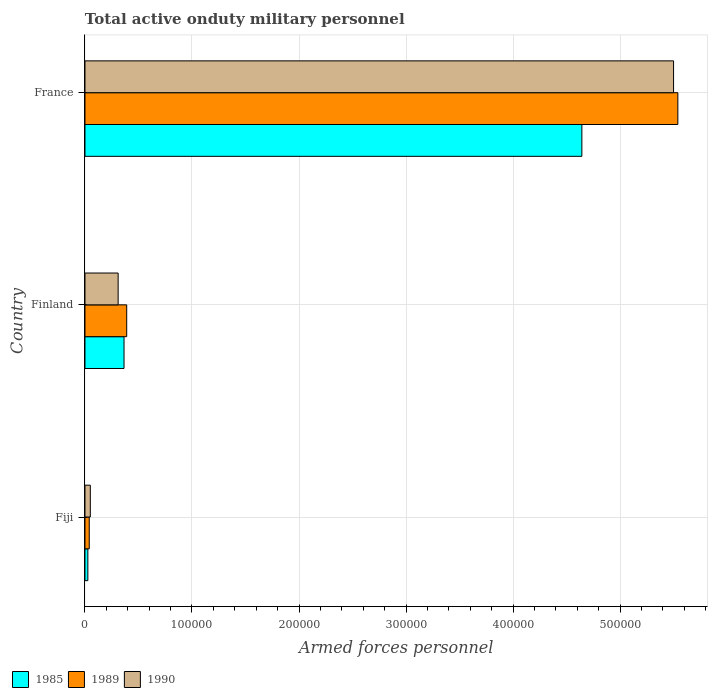How many different coloured bars are there?
Ensure brevity in your answer.  3. How many groups of bars are there?
Offer a terse response. 3. How many bars are there on the 3rd tick from the bottom?
Keep it short and to the point. 3. What is the label of the 3rd group of bars from the top?
Offer a terse response. Fiji. In how many cases, is the number of bars for a given country not equal to the number of legend labels?
Make the answer very short. 0. What is the number of armed forces personnel in 1989 in France?
Provide a short and direct response. 5.54e+05. Across all countries, what is the maximum number of armed forces personnel in 1990?
Offer a terse response. 5.50e+05. Across all countries, what is the minimum number of armed forces personnel in 1989?
Offer a terse response. 4000. In which country was the number of armed forces personnel in 1989 maximum?
Your response must be concise. France. In which country was the number of armed forces personnel in 1990 minimum?
Ensure brevity in your answer.  Fiji. What is the total number of armed forces personnel in 1990 in the graph?
Give a very brief answer. 5.86e+05. What is the difference between the number of armed forces personnel in 1990 in Fiji and that in France?
Ensure brevity in your answer.  -5.45e+05. What is the difference between the number of armed forces personnel in 1989 in Finland and the number of armed forces personnel in 1990 in France?
Your answer should be very brief. -5.11e+05. What is the average number of armed forces personnel in 1989 per country?
Your answer should be very brief. 1.99e+05. What is the difference between the number of armed forces personnel in 1989 and number of armed forces personnel in 1990 in Finland?
Offer a terse response. 8000. What is the ratio of the number of armed forces personnel in 1989 in Fiji to that in France?
Make the answer very short. 0.01. Is the difference between the number of armed forces personnel in 1989 in Finland and France greater than the difference between the number of armed forces personnel in 1990 in Finland and France?
Offer a terse response. Yes. What is the difference between the highest and the second highest number of armed forces personnel in 1985?
Offer a terse response. 4.28e+05. What is the difference between the highest and the lowest number of armed forces personnel in 1990?
Ensure brevity in your answer.  5.45e+05. Is the sum of the number of armed forces personnel in 1990 in Finland and France greater than the maximum number of armed forces personnel in 1989 across all countries?
Give a very brief answer. Yes. What does the 2nd bar from the top in France represents?
Keep it short and to the point. 1989. Is it the case that in every country, the sum of the number of armed forces personnel in 1989 and number of armed forces personnel in 1990 is greater than the number of armed forces personnel in 1985?
Your answer should be very brief. Yes. Are all the bars in the graph horizontal?
Keep it short and to the point. Yes. Where does the legend appear in the graph?
Provide a succinct answer. Bottom left. How are the legend labels stacked?
Offer a very short reply. Horizontal. What is the title of the graph?
Give a very brief answer. Total active onduty military personnel. Does "1993" appear as one of the legend labels in the graph?
Your response must be concise. No. What is the label or title of the X-axis?
Provide a succinct answer. Armed forces personnel. What is the label or title of the Y-axis?
Offer a very short reply. Country. What is the Armed forces personnel of 1985 in Fiji?
Your response must be concise. 2700. What is the Armed forces personnel in 1989 in Fiji?
Provide a succinct answer. 4000. What is the Armed forces personnel in 1990 in Fiji?
Make the answer very short. 5000. What is the Armed forces personnel of 1985 in Finland?
Offer a very short reply. 3.65e+04. What is the Armed forces personnel of 1989 in Finland?
Offer a terse response. 3.90e+04. What is the Armed forces personnel of 1990 in Finland?
Your answer should be compact. 3.10e+04. What is the Armed forces personnel of 1985 in France?
Provide a succinct answer. 4.64e+05. What is the Armed forces personnel in 1989 in France?
Offer a terse response. 5.54e+05. What is the Armed forces personnel in 1990 in France?
Ensure brevity in your answer.  5.50e+05. Across all countries, what is the maximum Armed forces personnel in 1985?
Your answer should be compact. 4.64e+05. Across all countries, what is the maximum Armed forces personnel of 1989?
Your response must be concise. 5.54e+05. Across all countries, what is the maximum Armed forces personnel in 1990?
Give a very brief answer. 5.50e+05. Across all countries, what is the minimum Armed forces personnel in 1985?
Your response must be concise. 2700. Across all countries, what is the minimum Armed forces personnel of 1989?
Your answer should be compact. 4000. Across all countries, what is the minimum Armed forces personnel of 1990?
Give a very brief answer. 5000. What is the total Armed forces personnel of 1985 in the graph?
Provide a succinct answer. 5.04e+05. What is the total Armed forces personnel in 1989 in the graph?
Give a very brief answer. 5.97e+05. What is the total Armed forces personnel of 1990 in the graph?
Make the answer very short. 5.86e+05. What is the difference between the Armed forces personnel of 1985 in Fiji and that in Finland?
Provide a short and direct response. -3.38e+04. What is the difference between the Armed forces personnel of 1989 in Fiji and that in Finland?
Keep it short and to the point. -3.50e+04. What is the difference between the Armed forces personnel of 1990 in Fiji and that in Finland?
Keep it short and to the point. -2.60e+04. What is the difference between the Armed forces personnel of 1985 in Fiji and that in France?
Ensure brevity in your answer.  -4.62e+05. What is the difference between the Armed forces personnel in 1989 in Fiji and that in France?
Your answer should be compact. -5.50e+05. What is the difference between the Armed forces personnel of 1990 in Fiji and that in France?
Provide a succinct answer. -5.45e+05. What is the difference between the Armed forces personnel of 1985 in Finland and that in France?
Keep it short and to the point. -4.28e+05. What is the difference between the Armed forces personnel in 1989 in Finland and that in France?
Provide a succinct answer. -5.15e+05. What is the difference between the Armed forces personnel in 1990 in Finland and that in France?
Your answer should be very brief. -5.19e+05. What is the difference between the Armed forces personnel of 1985 in Fiji and the Armed forces personnel of 1989 in Finland?
Keep it short and to the point. -3.63e+04. What is the difference between the Armed forces personnel of 1985 in Fiji and the Armed forces personnel of 1990 in Finland?
Ensure brevity in your answer.  -2.83e+04. What is the difference between the Armed forces personnel of 1989 in Fiji and the Armed forces personnel of 1990 in Finland?
Keep it short and to the point. -2.70e+04. What is the difference between the Armed forces personnel of 1985 in Fiji and the Armed forces personnel of 1989 in France?
Provide a succinct answer. -5.51e+05. What is the difference between the Armed forces personnel of 1985 in Fiji and the Armed forces personnel of 1990 in France?
Keep it short and to the point. -5.47e+05. What is the difference between the Armed forces personnel in 1989 in Fiji and the Armed forces personnel in 1990 in France?
Offer a very short reply. -5.46e+05. What is the difference between the Armed forces personnel in 1985 in Finland and the Armed forces personnel in 1989 in France?
Provide a short and direct response. -5.18e+05. What is the difference between the Armed forces personnel of 1985 in Finland and the Armed forces personnel of 1990 in France?
Give a very brief answer. -5.14e+05. What is the difference between the Armed forces personnel in 1989 in Finland and the Armed forces personnel in 1990 in France?
Keep it short and to the point. -5.11e+05. What is the average Armed forces personnel in 1985 per country?
Provide a short and direct response. 1.68e+05. What is the average Armed forces personnel in 1989 per country?
Ensure brevity in your answer.  1.99e+05. What is the average Armed forces personnel in 1990 per country?
Ensure brevity in your answer.  1.95e+05. What is the difference between the Armed forces personnel of 1985 and Armed forces personnel of 1989 in Fiji?
Make the answer very short. -1300. What is the difference between the Armed forces personnel in 1985 and Armed forces personnel in 1990 in Fiji?
Make the answer very short. -2300. What is the difference between the Armed forces personnel in 1989 and Armed forces personnel in 1990 in Fiji?
Your answer should be very brief. -1000. What is the difference between the Armed forces personnel in 1985 and Armed forces personnel in 1989 in Finland?
Make the answer very short. -2500. What is the difference between the Armed forces personnel of 1985 and Armed forces personnel of 1990 in Finland?
Offer a very short reply. 5500. What is the difference between the Armed forces personnel of 1989 and Armed forces personnel of 1990 in Finland?
Ensure brevity in your answer.  8000. What is the difference between the Armed forces personnel in 1985 and Armed forces personnel in 1989 in France?
Offer a very short reply. -8.97e+04. What is the difference between the Armed forces personnel of 1985 and Armed forces personnel of 1990 in France?
Give a very brief answer. -8.57e+04. What is the difference between the Armed forces personnel in 1989 and Armed forces personnel in 1990 in France?
Make the answer very short. 4000. What is the ratio of the Armed forces personnel in 1985 in Fiji to that in Finland?
Your answer should be very brief. 0.07. What is the ratio of the Armed forces personnel of 1989 in Fiji to that in Finland?
Make the answer very short. 0.1. What is the ratio of the Armed forces personnel in 1990 in Fiji to that in Finland?
Your answer should be compact. 0.16. What is the ratio of the Armed forces personnel of 1985 in Fiji to that in France?
Make the answer very short. 0.01. What is the ratio of the Armed forces personnel of 1989 in Fiji to that in France?
Provide a succinct answer. 0.01. What is the ratio of the Armed forces personnel in 1990 in Fiji to that in France?
Your answer should be compact. 0.01. What is the ratio of the Armed forces personnel in 1985 in Finland to that in France?
Offer a very short reply. 0.08. What is the ratio of the Armed forces personnel in 1989 in Finland to that in France?
Your response must be concise. 0.07. What is the ratio of the Armed forces personnel in 1990 in Finland to that in France?
Offer a terse response. 0.06. What is the difference between the highest and the second highest Armed forces personnel of 1985?
Provide a short and direct response. 4.28e+05. What is the difference between the highest and the second highest Armed forces personnel of 1989?
Your answer should be compact. 5.15e+05. What is the difference between the highest and the second highest Armed forces personnel of 1990?
Keep it short and to the point. 5.19e+05. What is the difference between the highest and the lowest Armed forces personnel of 1985?
Provide a succinct answer. 4.62e+05. What is the difference between the highest and the lowest Armed forces personnel of 1990?
Offer a terse response. 5.45e+05. 